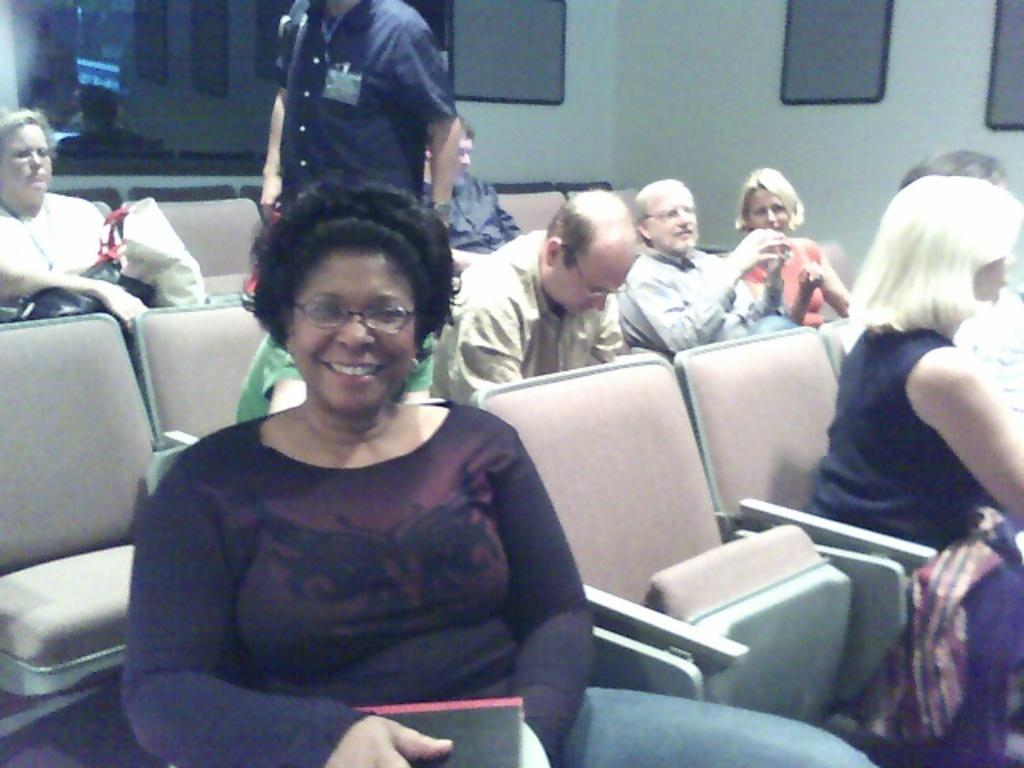What are the people in the image doing? The people in the image are sitting in chairs. What can be seen through the glass window in the image? The facts do not specify what can be seen through the glass window. What is on the wall in the image? There are frames on the wall in the image. What type of cheese is hanging from the ceiling in the image? There is no cheese present in the image. 